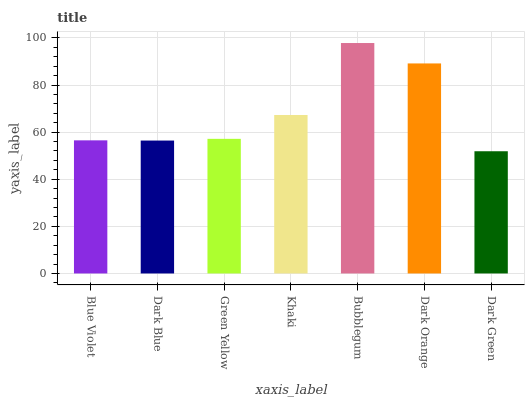Is Dark Green the minimum?
Answer yes or no. Yes. Is Bubblegum the maximum?
Answer yes or no. Yes. Is Dark Blue the minimum?
Answer yes or no. No. Is Dark Blue the maximum?
Answer yes or no. No. Is Blue Violet greater than Dark Blue?
Answer yes or no. Yes. Is Dark Blue less than Blue Violet?
Answer yes or no. Yes. Is Dark Blue greater than Blue Violet?
Answer yes or no. No. Is Blue Violet less than Dark Blue?
Answer yes or no. No. Is Green Yellow the high median?
Answer yes or no. Yes. Is Green Yellow the low median?
Answer yes or no. Yes. Is Dark Orange the high median?
Answer yes or no. No. Is Dark Blue the low median?
Answer yes or no. No. 